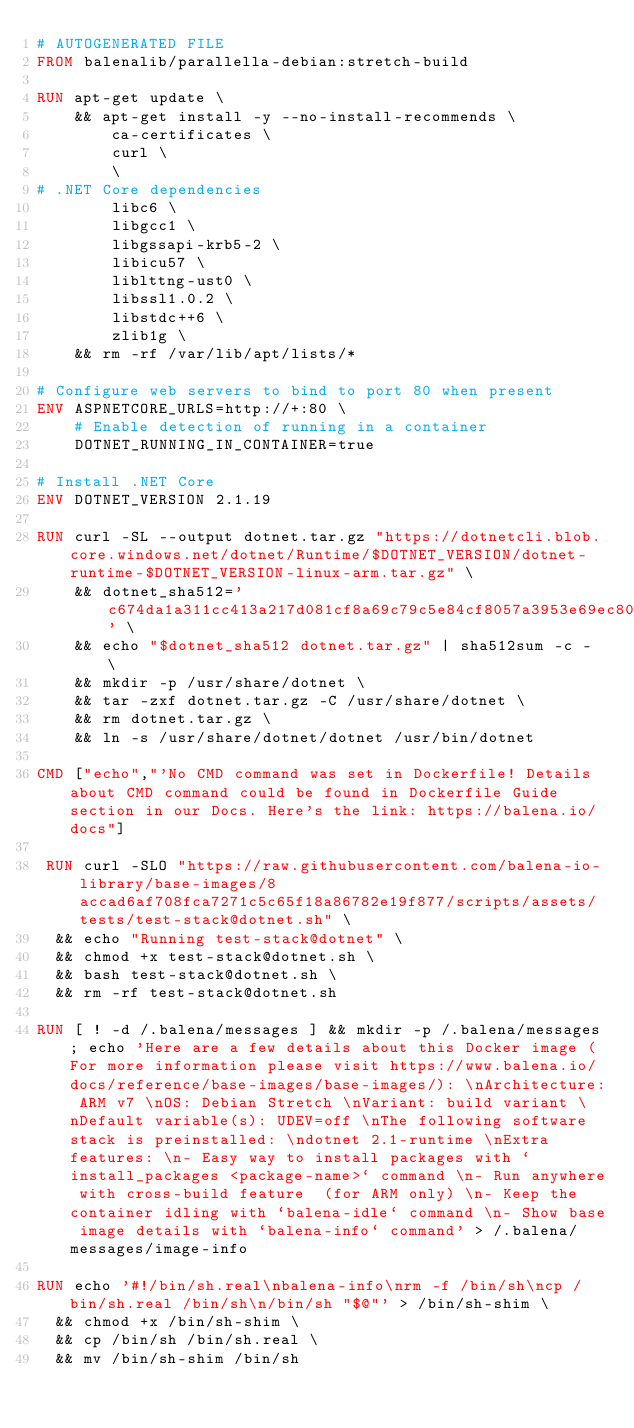<code> <loc_0><loc_0><loc_500><loc_500><_Dockerfile_># AUTOGENERATED FILE
FROM balenalib/parallella-debian:stretch-build

RUN apt-get update \
    && apt-get install -y --no-install-recommends \
        ca-certificates \
        curl \
        \
# .NET Core dependencies
        libc6 \
        libgcc1 \
        libgssapi-krb5-2 \
        libicu57 \
        liblttng-ust0 \
        libssl1.0.2 \
        libstdc++6 \
        zlib1g \
    && rm -rf /var/lib/apt/lists/*

# Configure web servers to bind to port 80 when present
ENV ASPNETCORE_URLS=http://+:80 \
    # Enable detection of running in a container
    DOTNET_RUNNING_IN_CONTAINER=true

# Install .NET Core
ENV DOTNET_VERSION 2.1.19

RUN curl -SL --output dotnet.tar.gz "https://dotnetcli.blob.core.windows.net/dotnet/Runtime/$DOTNET_VERSION/dotnet-runtime-$DOTNET_VERSION-linux-arm.tar.gz" \
    && dotnet_sha512='c674da1a311cc413a217d081cf8a69c79c5e84cf8057a3953e69ec80655840dd08332462a3a89010e094e1b62de737c95c07a3978a7f8aee6bd6e1c73f0928ec' \
    && echo "$dotnet_sha512 dotnet.tar.gz" | sha512sum -c - \
    && mkdir -p /usr/share/dotnet \
    && tar -zxf dotnet.tar.gz -C /usr/share/dotnet \
    && rm dotnet.tar.gz \
    && ln -s /usr/share/dotnet/dotnet /usr/bin/dotnet

CMD ["echo","'No CMD command was set in Dockerfile! Details about CMD command could be found in Dockerfile Guide section in our Docs. Here's the link: https://balena.io/docs"]

 RUN curl -SLO "https://raw.githubusercontent.com/balena-io-library/base-images/8accad6af708fca7271c5c65f18a86782e19f877/scripts/assets/tests/test-stack@dotnet.sh" \
  && echo "Running test-stack@dotnet" \
  && chmod +x test-stack@dotnet.sh \
  && bash test-stack@dotnet.sh \
  && rm -rf test-stack@dotnet.sh 

RUN [ ! -d /.balena/messages ] && mkdir -p /.balena/messages; echo 'Here are a few details about this Docker image (For more information please visit https://www.balena.io/docs/reference/base-images/base-images/): \nArchitecture: ARM v7 \nOS: Debian Stretch \nVariant: build variant \nDefault variable(s): UDEV=off \nThe following software stack is preinstalled: \ndotnet 2.1-runtime \nExtra features: \n- Easy way to install packages with `install_packages <package-name>` command \n- Run anywhere with cross-build feature  (for ARM only) \n- Keep the container idling with `balena-idle` command \n- Show base image details with `balena-info` command' > /.balena/messages/image-info

RUN echo '#!/bin/sh.real\nbalena-info\nrm -f /bin/sh\ncp /bin/sh.real /bin/sh\n/bin/sh "$@"' > /bin/sh-shim \
	&& chmod +x /bin/sh-shim \
	&& cp /bin/sh /bin/sh.real \
	&& mv /bin/sh-shim /bin/sh</code> 